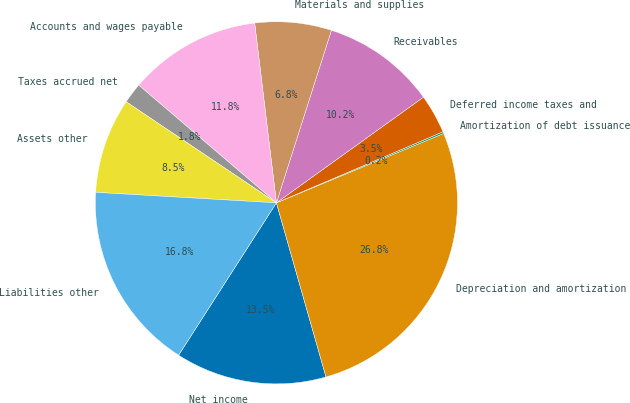Convert chart. <chart><loc_0><loc_0><loc_500><loc_500><pie_chart><fcel>Net income<fcel>Depreciation and amortization<fcel>Amortization of debt issuance<fcel>Deferred income taxes and<fcel>Receivables<fcel>Materials and supplies<fcel>Accounts and wages payable<fcel>Taxes accrued net<fcel>Assets other<fcel>Liabilities other<nl><fcel>13.5%<fcel>26.84%<fcel>0.16%<fcel>3.5%<fcel>10.17%<fcel>6.83%<fcel>11.83%<fcel>1.83%<fcel>8.5%<fcel>16.84%<nl></chart> 